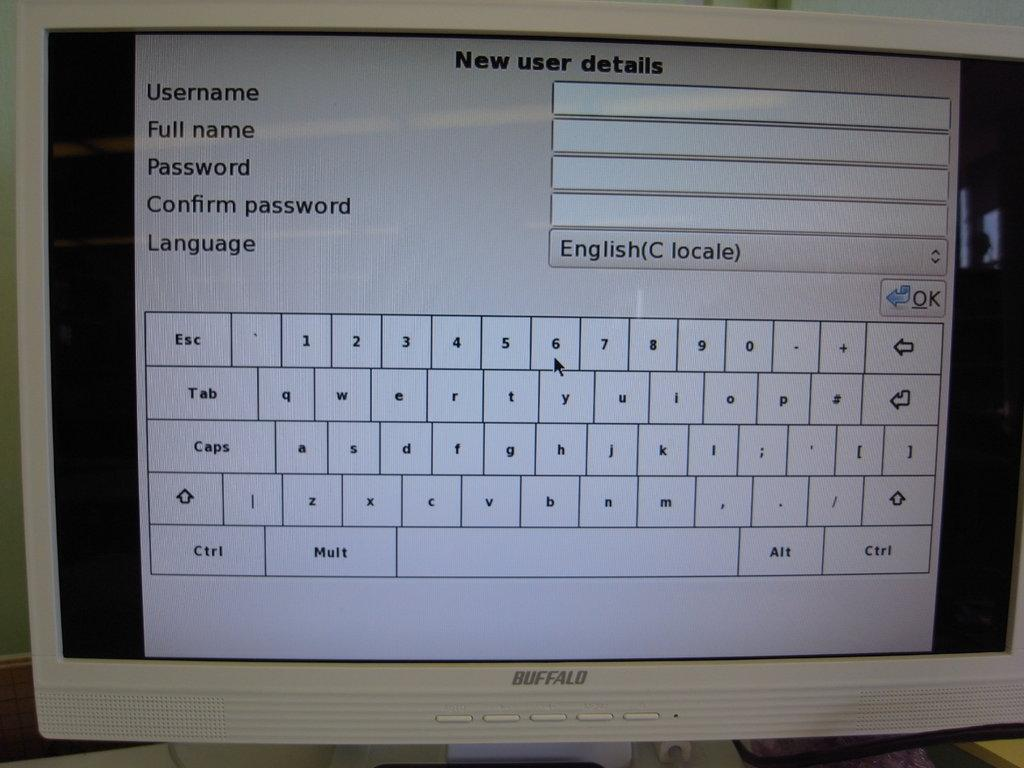<image>
Give a short and clear explanation of the subsequent image. A computer monitor shows a "New user details" window. 